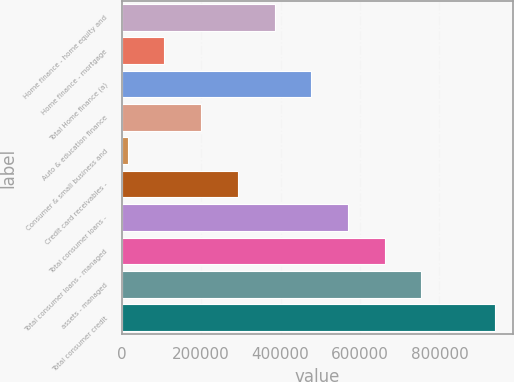<chart> <loc_0><loc_0><loc_500><loc_500><bar_chart><fcel>Home finance - home equity and<fcel>Home finance - mortgage<fcel>Total Home finance (a)<fcel>Auto & education finance<fcel>Consumer & small business and<fcel>Credit card receivables -<fcel>Total consumer loans -<fcel>Total consumer loans - managed<fcel>assets - managed<fcel>Total consumer credit<nl><fcel>384679<fcel>107500<fcel>477072<fcel>199893<fcel>15107<fcel>292286<fcel>569466<fcel>661859<fcel>754252<fcel>939038<nl></chart> 